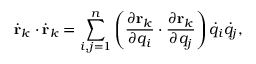<formula> <loc_0><loc_0><loc_500><loc_500>{ \dot { r } } _ { k } \cdot { \dot { r } } _ { k } = \sum _ { i , j = 1 } ^ { n } \left ( { \frac { \partial r _ { k } } { \partial q _ { i } } } \cdot { \frac { \partial r _ { k } } { \partial q _ { j } } } \right ) { \dot { q } } _ { i } { \dot { q } } _ { j } ,</formula> 